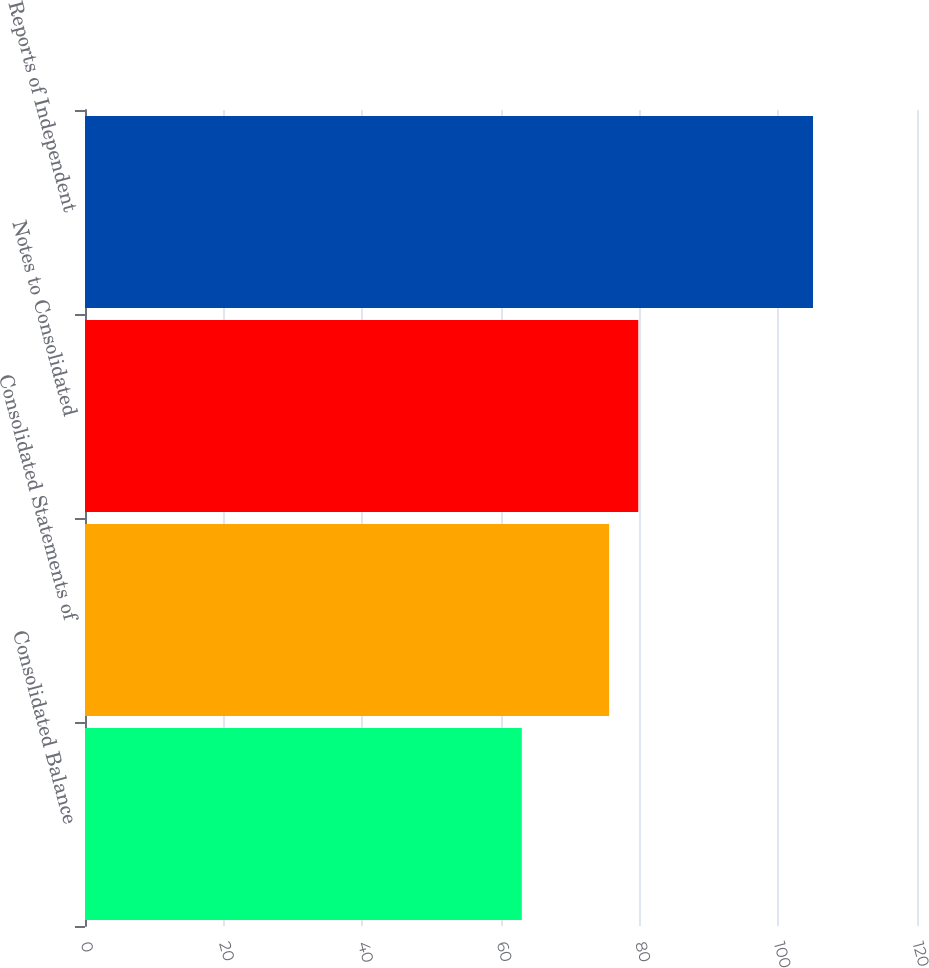<chart> <loc_0><loc_0><loc_500><loc_500><bar_chart><fcel>Consolidated Balance<fcel>Consolidated Statements of<fcel>Notes to Consolidated<fcel>Reports of Independent<nl><fcel>63<fcel>75.6<fcel>79.8<fcel>105<nl></chart> 